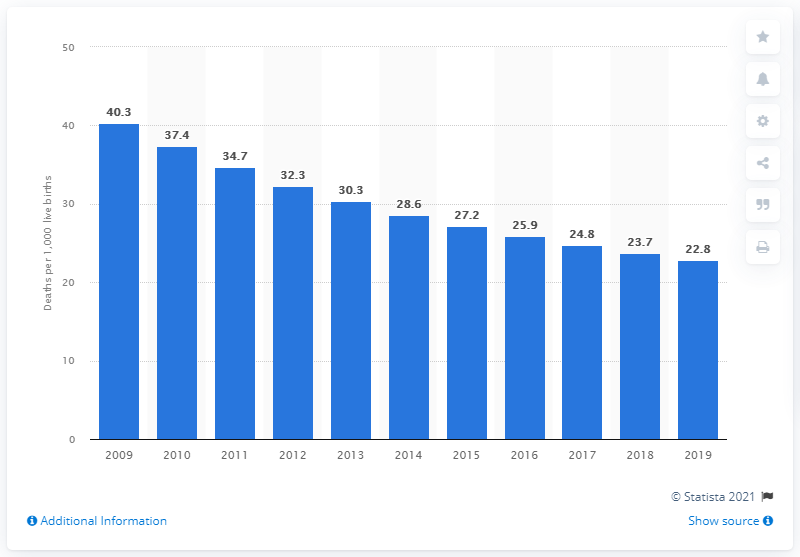Point out several critical features in this image. In 2019, the infant mortality rate in Cambodia was 22.8. 